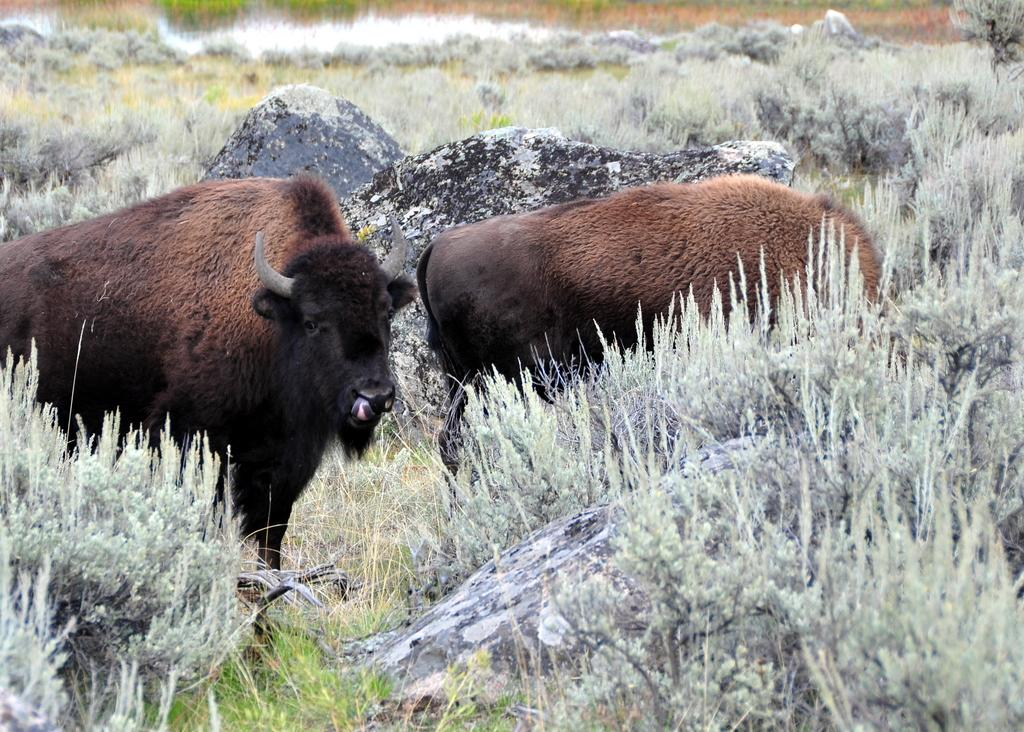What type of setting is depicted in the image? The image is an outside view. What animals can be seen in the image? There are two brown animals in the image. What type of vegetation is visible at the bottom of the image? There is grass visible at the bottom of the image. What other natural elements are present in the image? There are plants and rocks in the image. What type of pets are visible in the image? There are no pets visible in the image; the two brown animals are not identified as pets. What type of vacation destination is depicted in the image? The image does not depict a vacation destination; it is an outdoor scene with animals, grass, plants, and rocks. 